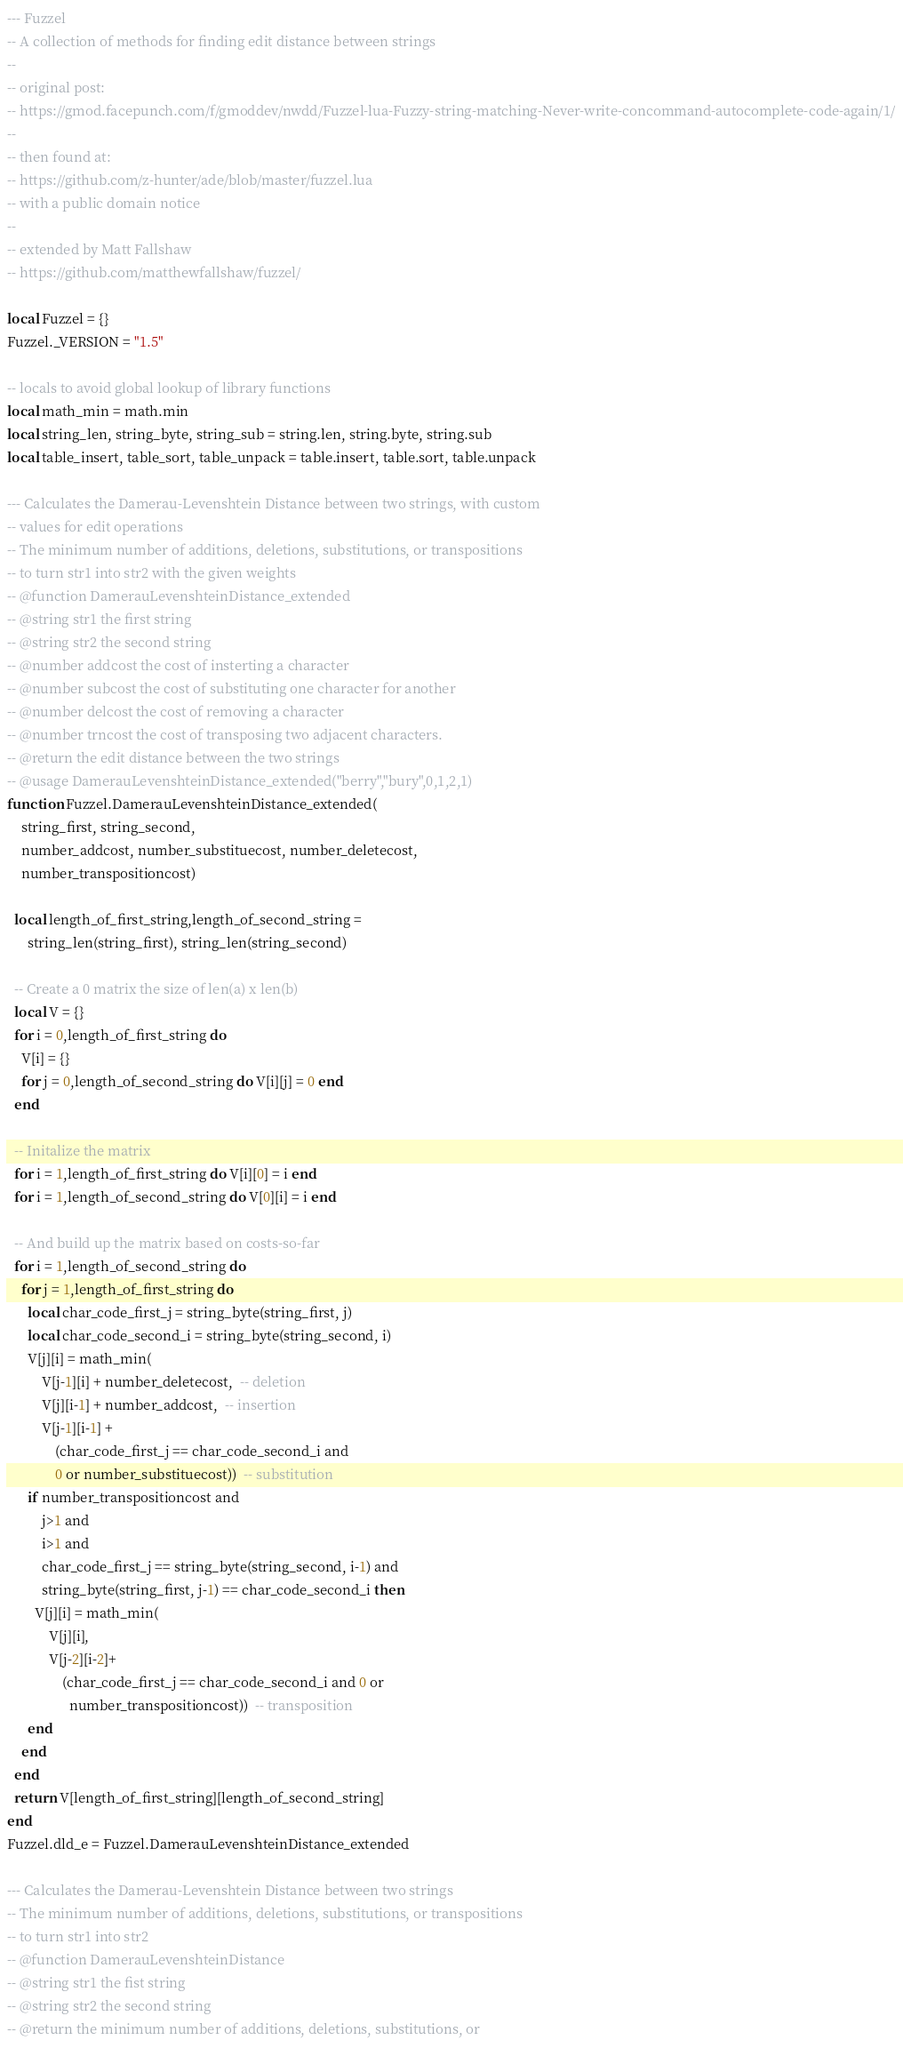<code> <loc_0><loc_0><loc_500><loc_500><_Lua_>--- Fuzzel
-- A collection of methods for finding edit distance between strings
--
-- original post:
-- https://gmod.facepunch.com/f/gmoddev/nwdd/Fuzzel-lua-Fuzzy-string-matching-Never-write-concommand-autocomplete-code-again/1/
--
-- then found at:
-- https://github.com/z-hunter/ade/blob/master/fuzzel.lua
-- with a public domain notice
--
-- extended by Matt Fallshaw
-- https://github.com/matthewfallshaw/fuzzel/

local Fuzzel = {}
Fuzzel._VERSION = "1.5"

-- locals to avoid global lookup of library functions
local math_min = math.min
local string_len, string_byte, string_sub = string.len, string.byte, string.sub
local table_insert, table_sort, table_unpack = table.insert, table.sort, table.unpack

--- Calculates the Damerau-Levenshtein Distance between two strings, with custom
-- values for edit operations
-- The minimum number of additions, deletions, substitutions, or transpositions
-- to turn str1 into str2 with the given weights
-- @function DamerauLevenshteinDistance_extended
-- @string str1 the first string
-- @string str2 the second string
-- @number addcost the cost of insterting a character
-- @number subcost the cost of substituting one character for another
-- @number delcost the cost of removing a character
-- @number trncost the cost of transposing two adjacent characters.
-- @return the edit distance between the two strings
-- @usage DamerauLevenshteinDistance_extended("berry","bury",0,1,2,1)
function Fuzzel.DamerauLevenshteinDistance_extended(
    string_first, string_second,
    number_addcost, number_substituecost, number_deletecost,
    number_transpositioncost)

  local length_of_first_string,length_of_second_string =
      string_len(string_first), string_len(string_second)

  -- Create a 0 matrix the size of len(a) x len(b)
  local V = {}
  for i = 0,length_of_first_string do
    V[i] = {}
    for j = 0,length_of_second_string do V[i][j] = 0 end
  end

  -- Initalize the matrix
  for i = 1,length_of_first_string do V[i][0] = i end
  for i = 1,length_of_second_string do V[0][i] = i end

  -- And build up the matrix based on costs-so-far
  for i = 1,length_of_second_string do
    for j = 1,length_of_first_string do
      local char_code_first_j = string_byte(string_first, j)
      local char_code_second_i = string_byte(string_second, i)
      V[j][i] = math_min(
          V[j-1][i] + number_deletecost,  -- deletion
          V[j][i-1] + number_addcost,  -- insertion
          V[j-1][i-1] +
              (char_code_first_j == char_code_second_i and
              0 or number_substituecost))  -- substitution
      if number_transpositioncost and
          j>1 and
          i>1 and
          char_code_first_j == string_byte(string_second, i-1) and
          string_byte(string_first, j-1) == char_code_second_i then
        V[j][i] = math_min(
            V[j][i],
            V[j-2][i-2]+
                (char_code_first_j == char_code_second_i and 0 or
                  number_transpositioncost))  -- transposition
      end
    end
  end
  return V[length_of_first_string][length_of_second_string]
end
Fuzzel.dld_e = Fuzzel.DamerauLevenshteinDistance_extended

--- Calculates the Damerau-Levenshtein Distance between two strings
-- The minimum number of additions, deletions, substitutions, or transpositions
-- to turn str1 into str2
-- @function DamerauLevenshteinDistance
-- @string str1 the fist string
-- @string str2 the second string
-- @return the minimum number of additions, deletions, substitutions, or</code> 